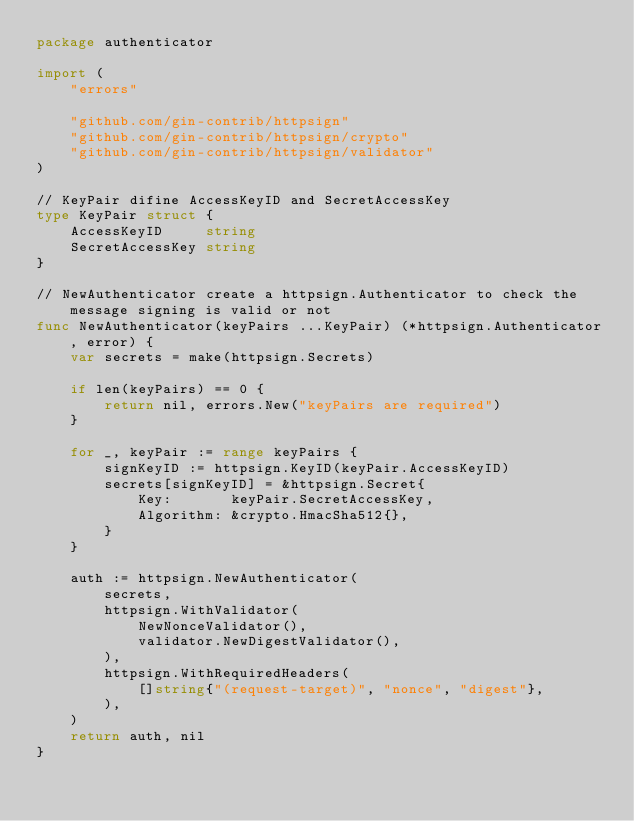Convert code to text. <code><loc_0><loc_0><loc_500><loc_500><_Go_>package authenticator

import (
	"errors"

	"github.com/gin-contrib/httpsign"
	"github.com/gin-contrib/httpsign/crypto"
	"github.com/gin-contrib/httpsign/validator"
)

// KeyPair difine AccessKeyID and SecretAccessKey
type KeyPair struct {
	AccessKeyID     string
	SecretAccessKey string
}

// NewAuthenticator create a httpsign.Authenticator to check the message signing is valid or not
func NewAuthenticator(keyPairs ...KeyPair) (*httpsign.Authenticator, error) {
	var secrets = make(httpsign.Secrets)

	if len(keyPairs) == 0 {
		return nil, errors.New("keyPairs are required")
	}

	for _, keyPair := range keyPairs {
		signKeyID := httpsign.KeyID(keyPair.AccessKeyID)
		secrets[signKeyID] = &httpsign.Secret{
			Key:       keyPair.SecretAccessKey,
			Algorithm: &crypto.HmacSha512{},
		}
	}

	auth := httpsign.NewAuthenticator(
		secrets,
		httpsign.WithValidator(
			NewNonceValidator(),
			validator.NewDigestValidator(),
		),
		httpsign.WithRequiredHeaders(
			[]string{"(request-target)", "nonce", "digest"},
		),
	)
	return auth, nil
}
</code> 